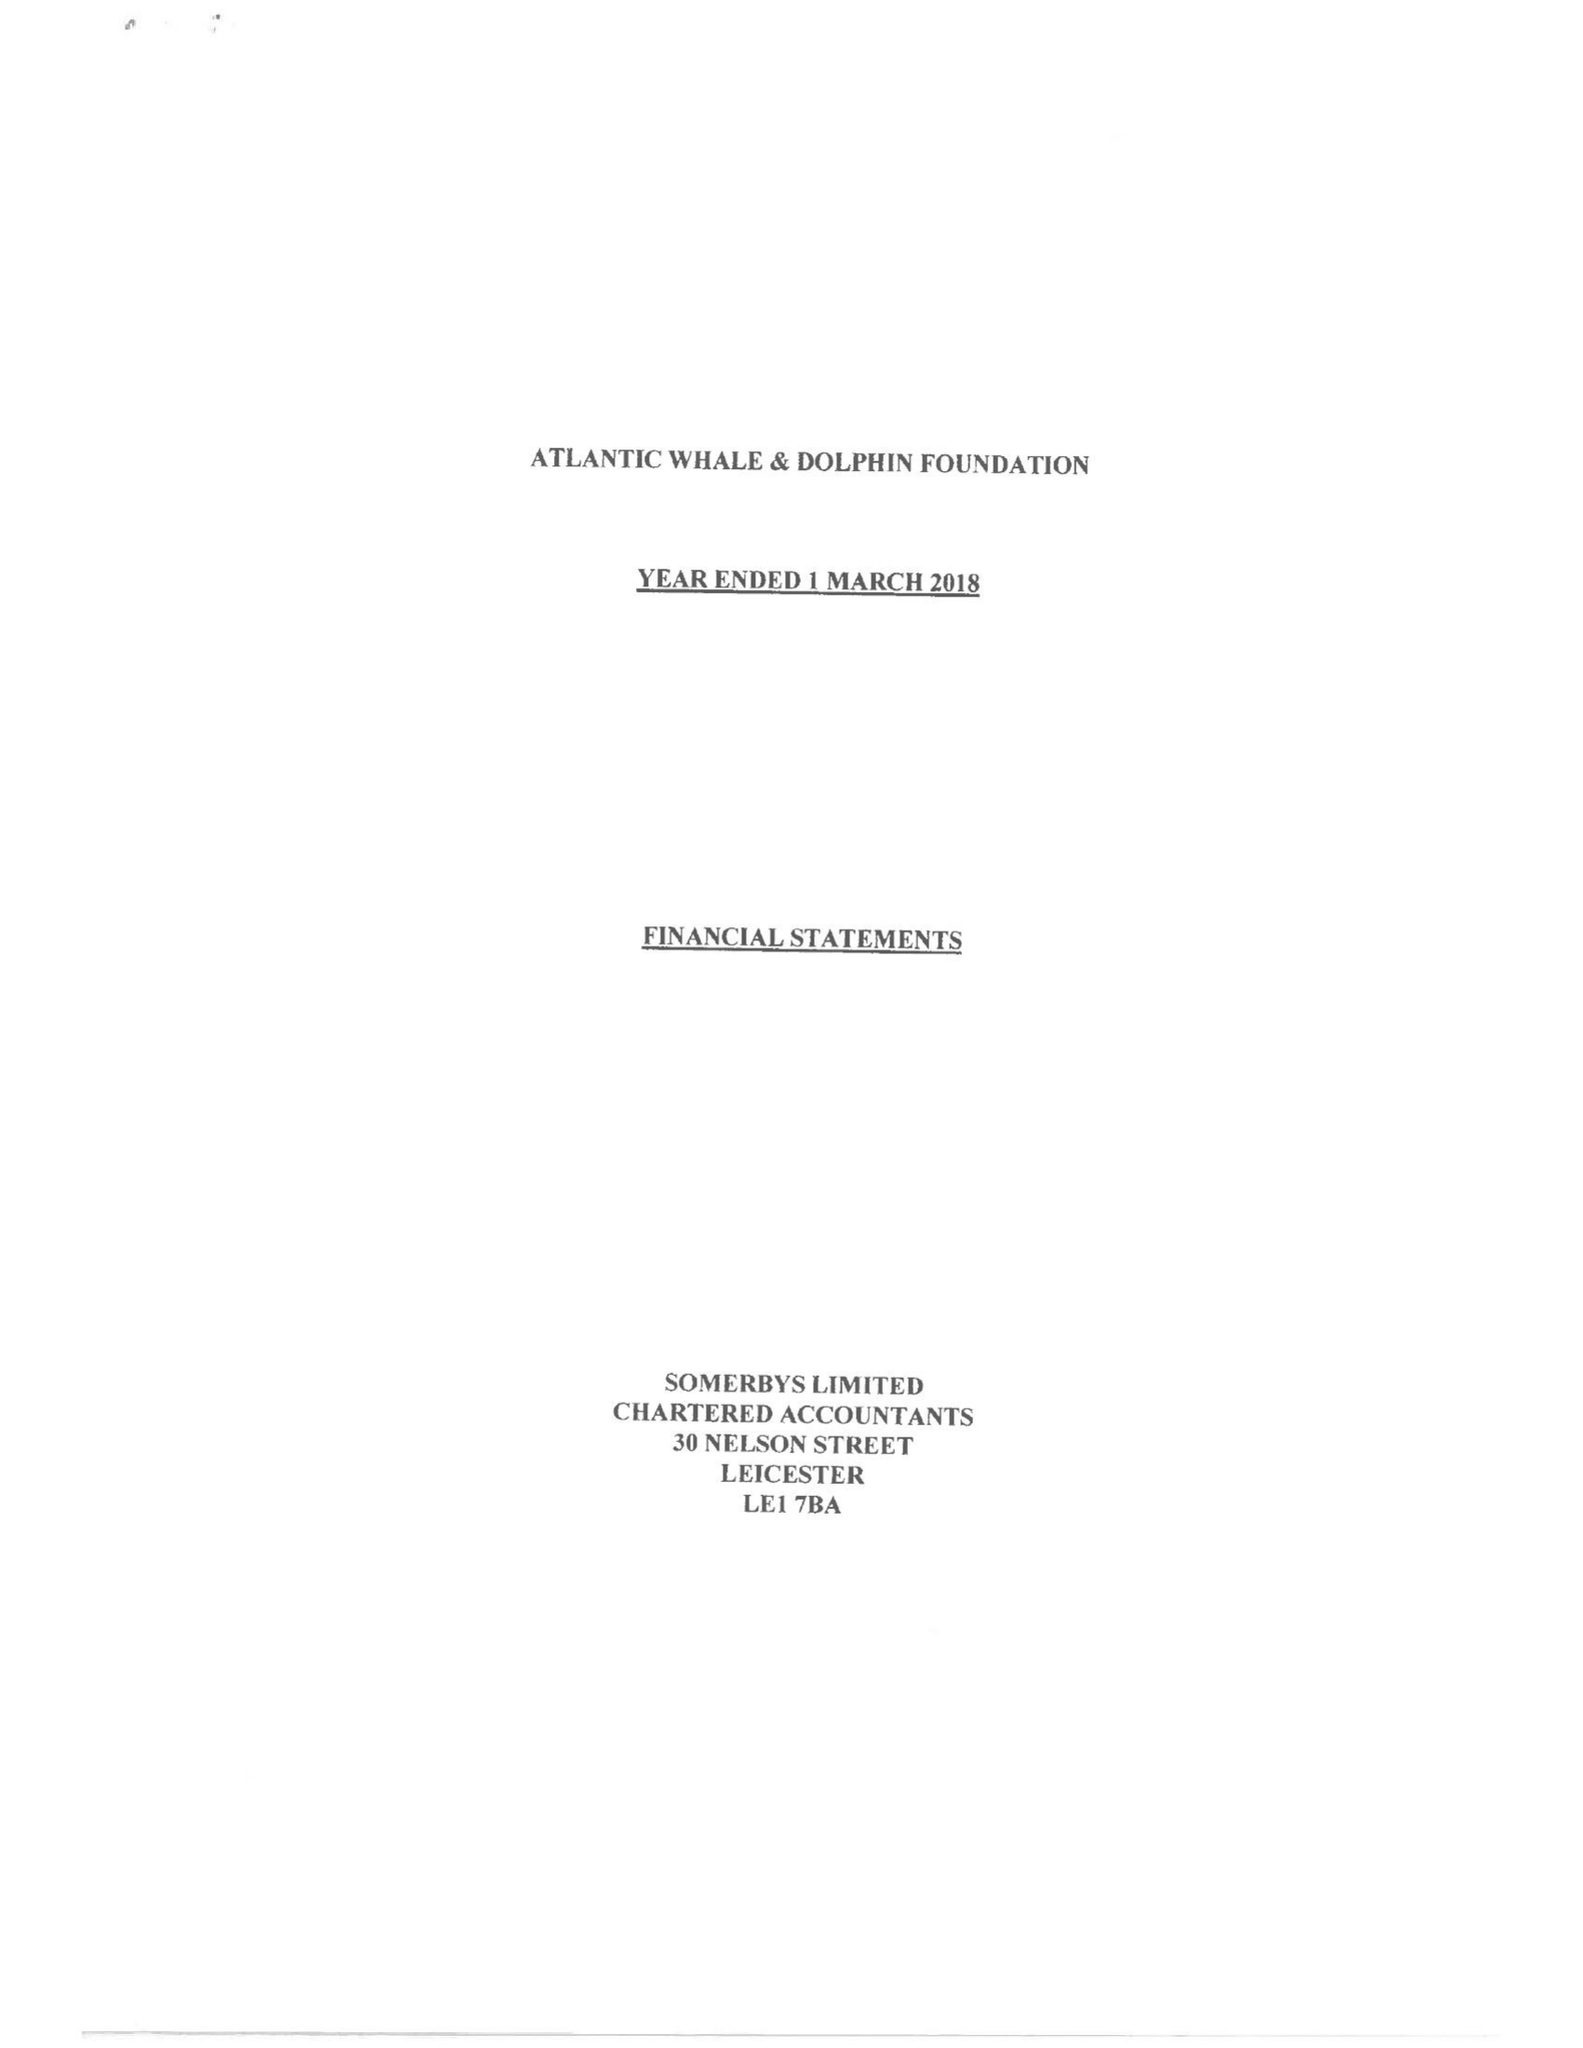What is the value for the spending_annually_in_british_pounds?
Answer the question using a single word or phrase. 135297.00 